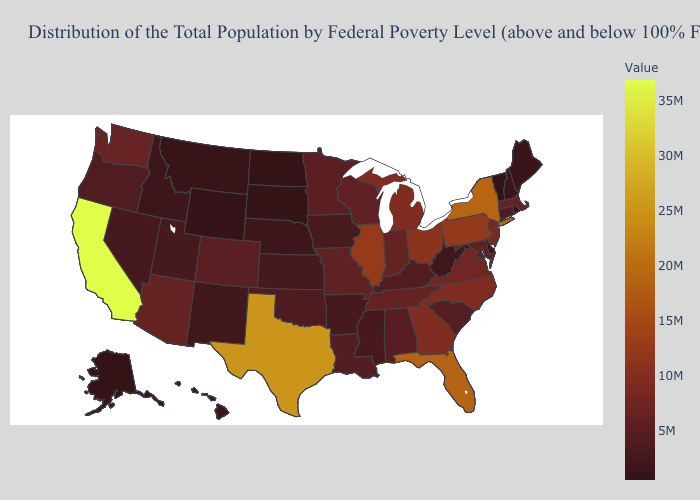Does Indiana have the highest value in the MidWest?
Short answer required. No. Does Maine have the lowest value in the Northeast?
Be succinct. No. Does California have the highest value in the USA?
Give a very brief answer. Yes. Does Texas have the highest value in the South?
Answer briefly. Yes. Does Tennessee have the highest value in the USA?
Be succinct. No. 